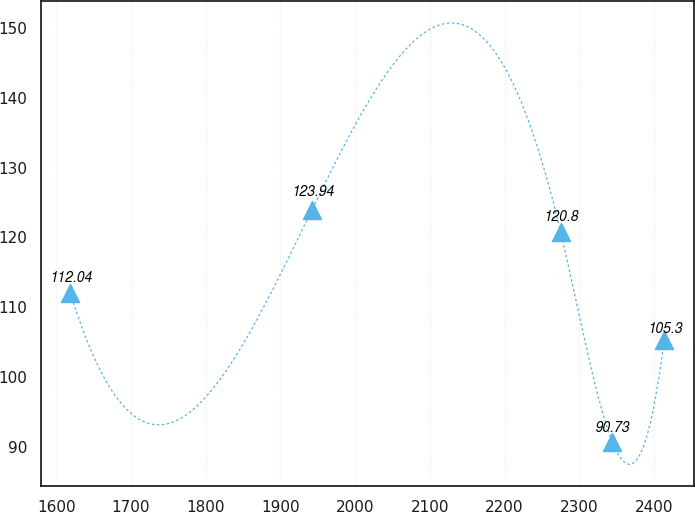Convert chart to OTSL. <chart><loc_0><loc_0><loc_500><loc_500><line_chart><ecel><fcel>Unnamed: 1<nl><fcel>1619.01<fcel>112.04<nl><fcel>1942.31<fcel>123.94<nl><fcel>2275.04<fcel>120.8<nl><fcel>2344.34<fcel>90.73<nl><fcel>2413.64<fcel>105.3<nl></chart> 